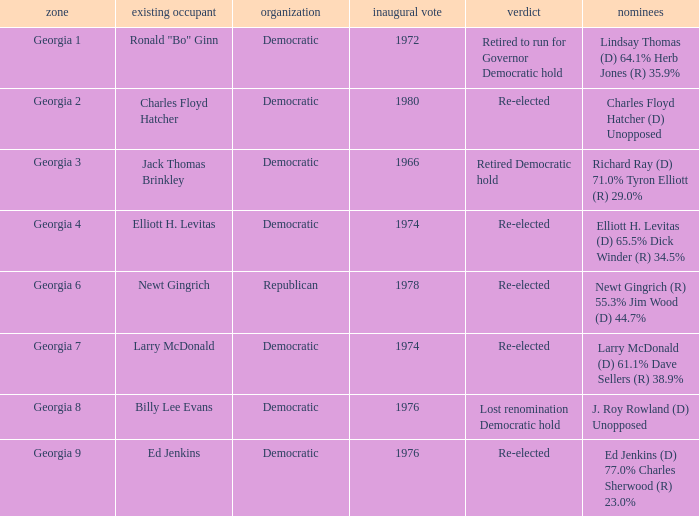Name the party for jack thomas brinkley Democratic. 